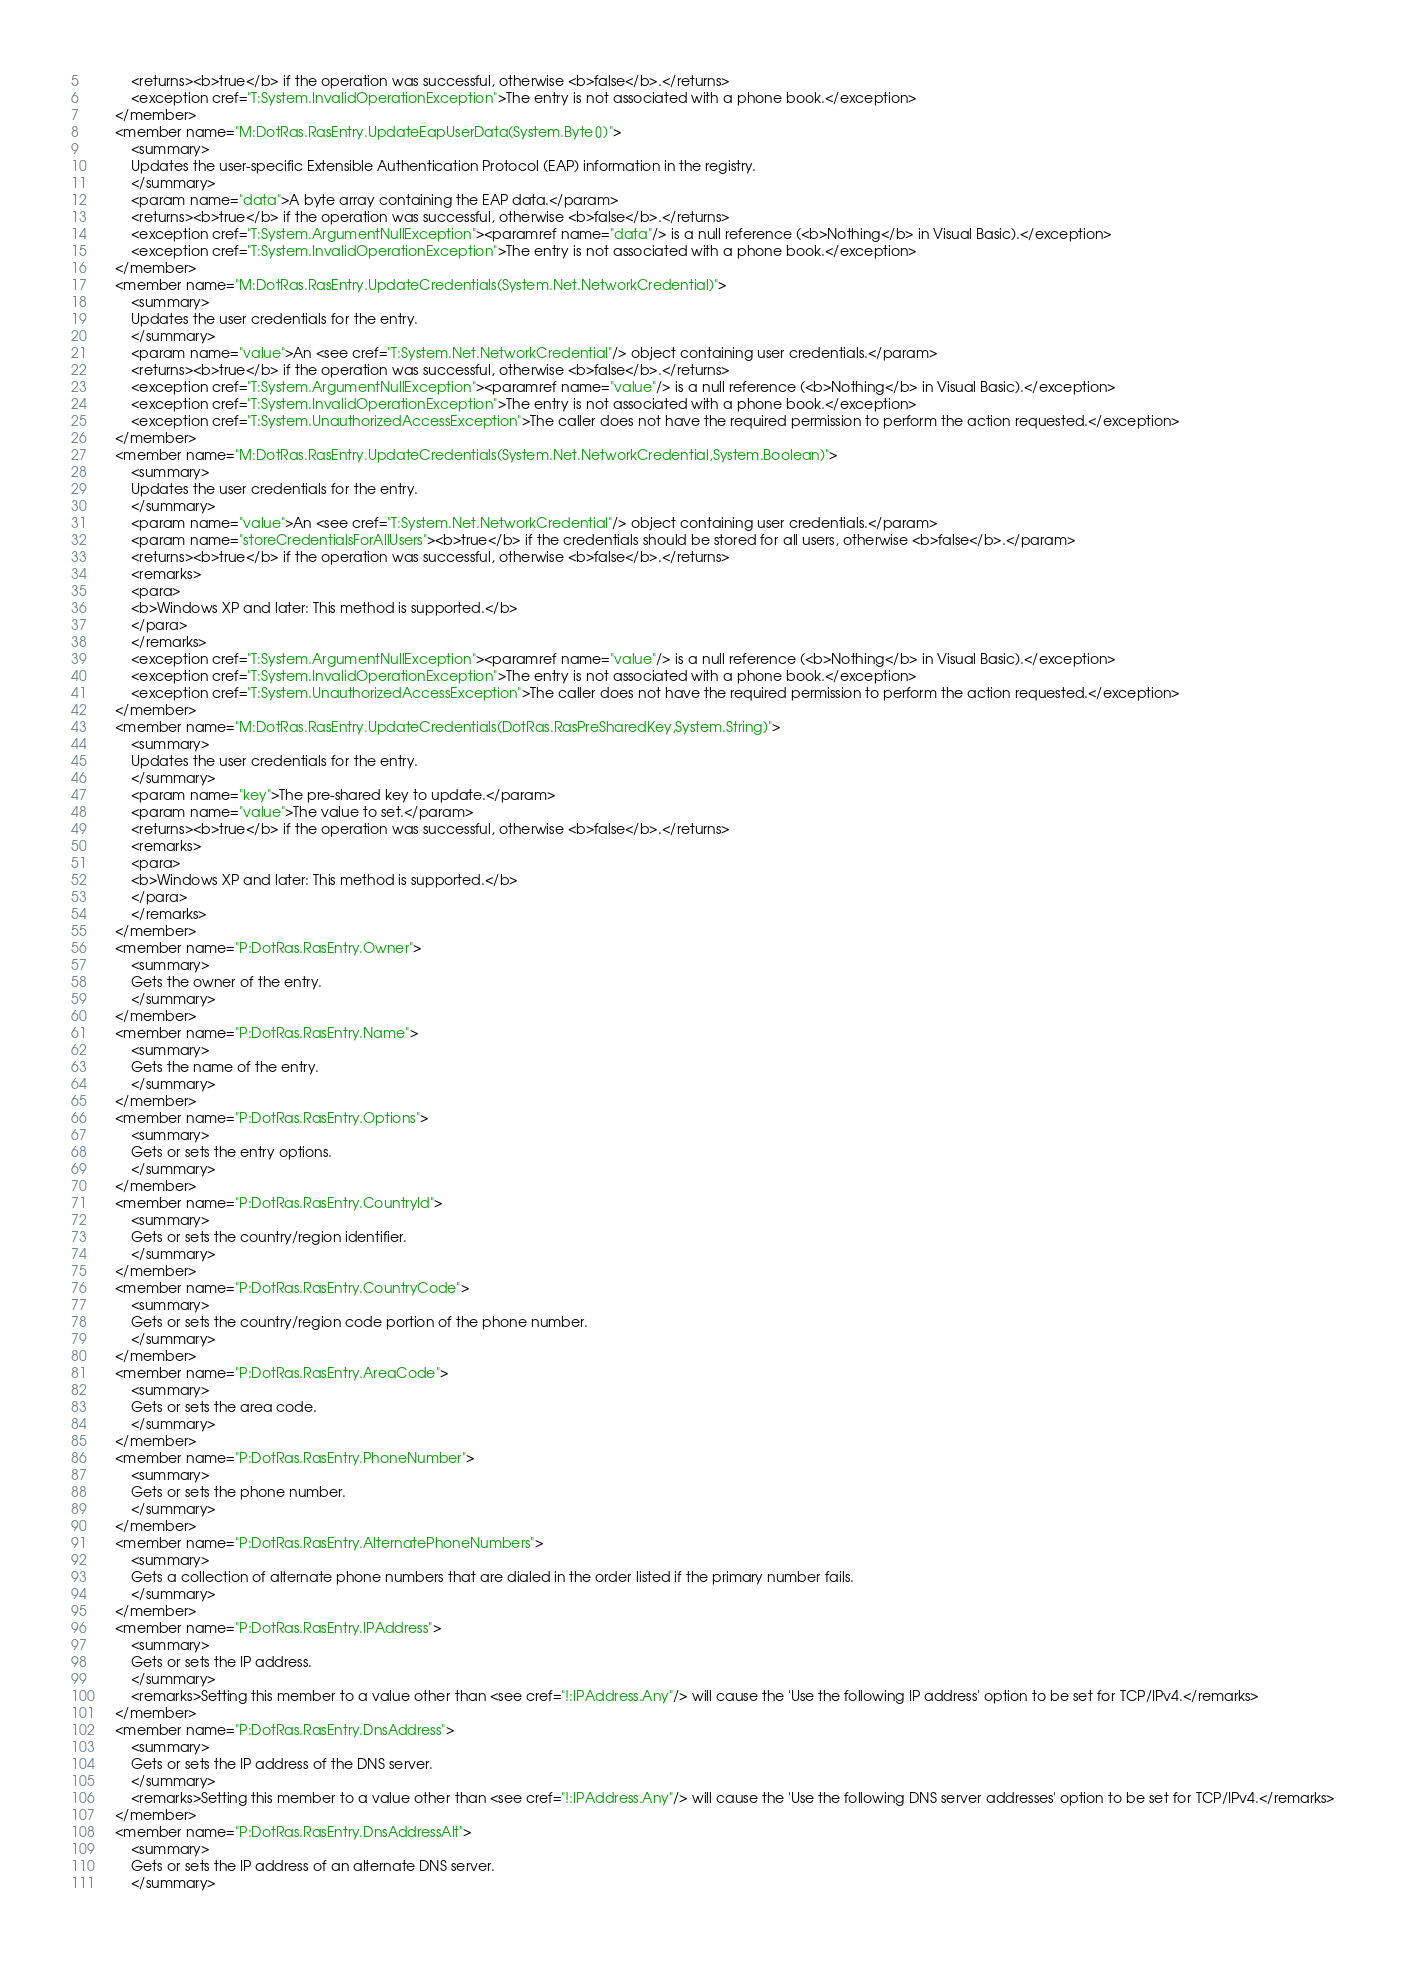Convert code to text. <code><loc_0><loc_0><loc_500><loc_500><_XML_>            <returns><b>true</b> if the operation was successful, otherwise <b>false</b>.</returns>
            <exception cref="T:System.InvalidOperationException">The entry is not associated with a phone book.</exception>
        </member>
        <member name="M:DotRas.RasEntry.UpdateEapUserData(System.Byte[])">
            <summary>
            Updates the user-specific Extensible Authentication Protocol (EAP) information in the registry.
            </summary>
            <param name="data">A byte array containing the EAP data.</param>
            <returns><b>true</b> if the operation was successful, otherwise <b>false</b>.</returns>
            <exception cref="T:System.ArgumentNullException"><paramref name="data"/> is a null reference (<b>Nothing</b> in Visual Basic).</exception>
            <exception cref="T:System.InvalidOperationException">The entry is not associated with a phone book.</exception>
        </member>
        <member name="M:DotRas.RasEntry.UpdateCredentials(System.Net.NetworkCredential)">
            <summary>
            Updates the user credentials for the entry.
            </summary>
            <param name="value">An <see cref="T:System.Net.NetworkCredential"/> object containing user credentials.</param>
            <returns><b>true</b> if the operation was successful, otherwise <b>false</b>.</returns>
            <exception cref="T:System.ArgumentNullException"><paramref name="value"/> is a null reference (<b>Nothing</b> in Visual Basic).</exception>
            <exception cref="T:System.InvalidOperationException">The entry is not associated with a phone book.</exception>
            <exception cref="T:System.UnauthorizedAccessException">The caller does not have the required permission to perform the action requested.</exception>
        </member>
        <member name="M:DotRas.RasEntry.UpdateCredentials(System.Net.NetworkCredential,System.Boolean)">
            <summary>
            Updates the user credentials for the entry.
            </summary>
            <param name="value">An <see cref="T:System.Net.NetworkCredential"/> object containing user credentials.</param>
            <param name="storeCredentialsForAllUsers"><b>true</b> if the credentials should be stored for all users, otherwise <b>false</b>.</param>
            <returns><b>true</b> if the operation was successful, otherwise <b>false</b>.</returns>
            <remarks>
            <para>
            <b>Windows XP and later: This method is supported.</b>
            </para>
            </remarks>
            <exception cref="T:System.ArgumentNullException"><paramref name="value"/> is a null reference (<b>Nothing</b> in Visual Basic).</exception>
            <exception cref="T:System.InvalidOperationException">The entry is not associated with a phone book.</exception>
            <exception cref="T:System.UnauthorizedAccessException">The caller does not have the required permission to perform the action requested.</exception>
        </member>
        <member name="M:DotRas.RasEntry.UpdateCredentials(DotRas.RasPreSharedKey,System.String)">
            <summary>
            Updates the user credentials for the entry.
            </summary>
            <param name="key">The pre-shared key to update.</param>
            <param name="value">The value to set.</param>
            <returns><b>true</b> if the operation was successful, otherwise <b>false</b>.</returns>
            <remarks>
            <para>
            <b>Windows XP and later: This method is supported.</b>
            </para>
            </remarks>
        </member>
        <member name="P:DotRas.RasEntry.Owner">
            <summary>
            Gets the owner of the entry.
            </summary>
        </member>
        <member name="P:DotRas.RasEntry.Name">
            <summary>
            Gets the name of the entry.
            </summary>
        </member>
        <member name="P:DotRas.RasEntry.Options">
            <summary>
            Gets or sets the entry options.
            </summary>
        </member>
        <member name="P:DotRas.RasEntry.CountryId">
            <summary>
            Gets or sets the country/region identifier.
            </summary>
        </member>
        <member name="P:DotRas.RasEntry.CountryCode">
            <summary>
            Gets or sets the country/region code portion of the phone number.
            </summary>
        </member>
        <member name="P:DotRas.RasEntry.AreaCode">
            <summary>
            Gets or sets the area code.
            </summary>
        </member>
        <member name="P:DotRas.RasEntry.PhoneNumber">
            <summary>
            Gets or sets the phone number.
            </summary>
        </member>
        <member name="P:DotRas.RasEntry.AlternatePhoneNumbers">
            <summary>
            Gets a collection of alternate phone numbers that are dialed in the order listed if the primary number fails.
            </summary>
        </member>
        <member name="P:DotRas.RasEntry.IPAddress">
            <summary>
            Gets or sets the IP address.
            </summary>
            <remarks>Setting this member to a value other than <see cref="!:IPAddress.Any"/> will cause the 'Use the following IP address' option to be set for TCP/IPv4.</remarks>
        </member>
        <member name="P:DotRas.RasEntry.DnsAddress">
            <summary>
            Gets or sets the IP address of the DNS server.
            </summary>
            <remarks>Setting this member to a value other than <see cref="!:IPAddress.Any"/> will cause the 'Use the following DNS server addresses' option to be set for TCP/IPv4.</remarks>
        </member>
        <member name="P:DotRas.RasEntry.DnsAddressAlt">
            <summary>
            Gets or sets the IP address of an alternate DNS server.
            </summary></code> 